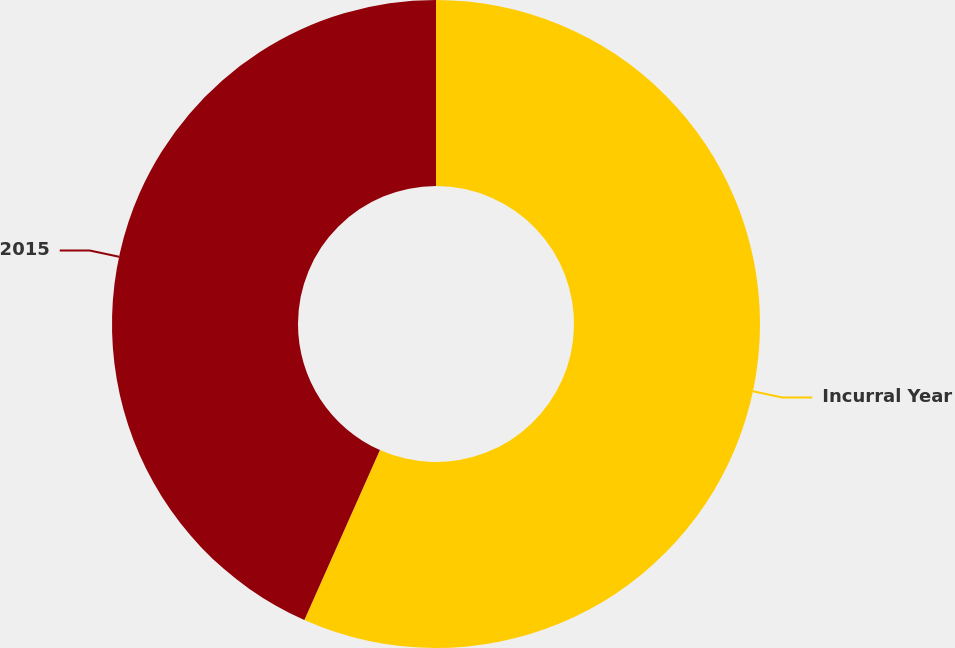<chart> <loc_0><loc_0><loc_500><loc_500><pie_chart><fcel>Incurral Year<fcel>2015<nl><fcel>56.66%<fcel>43.34%<nl></chart> 